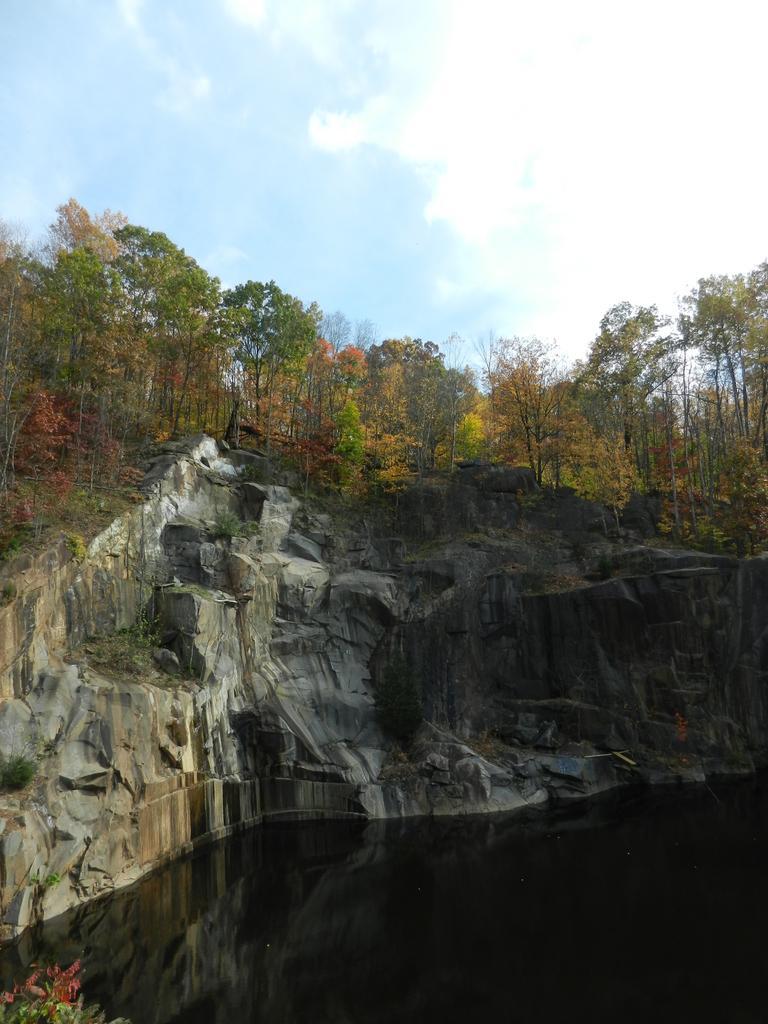Please provide a concise description of this image. In this image I can see the water, rock and many trees. In the background I can see the clouds and the blue sky. 